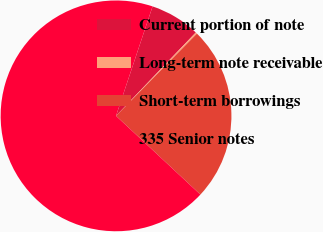<chart> <loc_0><loc_0><loc_500><loc_500><pie_chart><fcel>Current portion of note<fcel>Long-term note receivable<fcel>Short-term borrowings<fcel>335 Senior notes<nl><fcel>7.02%<fcel>0.22%<fcel>24.58%<fcel>68.19%<nl></chart> 